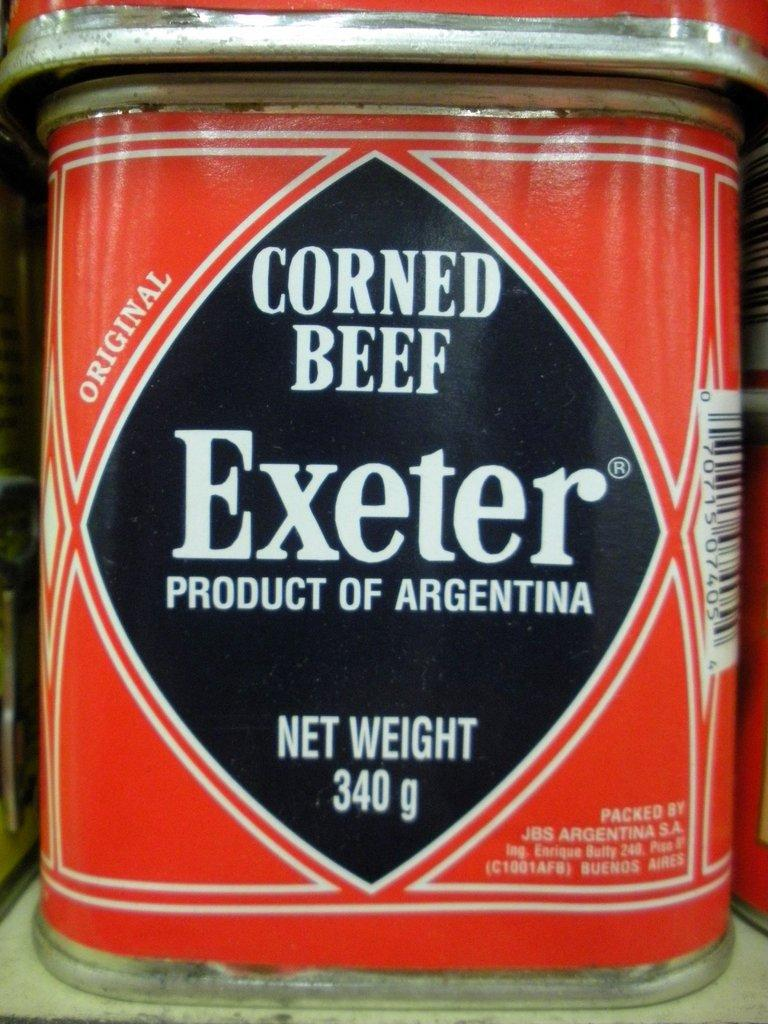<image>
Offer a succinct explanation of the picture presented. A can of corned beef from Argentina has a weight of 340 grams. 